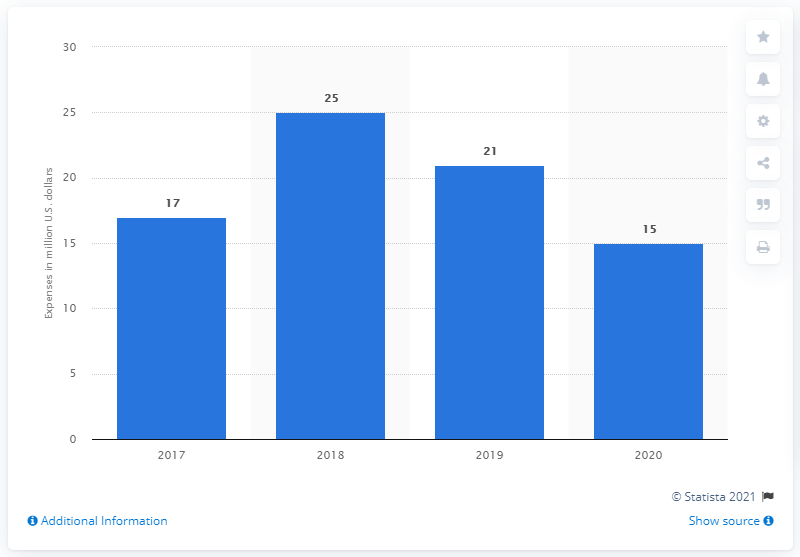Specify some key components in this picture. NVIDIA spent approximately 15 billion dollars on advertising in 2020. NVIDIA's advertising expenditure in 2020 was approximately $15 million. NVIDIA spent $21 million on advertising in the 2019 fiscal year. During the 2019 fiscal year, NVIDIA spent 21 on advertising. 